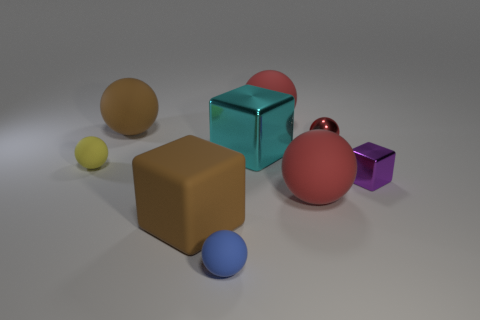The metal block behind the purple cube is what color?
Ensure brevity in your answer.  Cyan. There is a brown thing that is behind the tiny red shiny thing on the left side of the small purple cube; what is its shape?
Provide a short and direct response. Sphere. Do the large cyan object and the large ball that is on the left side of the large cyan object have the same material?
Ensure brevity in your answer.  No. How many red rubber balls are the same size as the yellow thing?
Your answer should be compact. 0. Is the number of cyan shiny cubes that are right of the purple metal block less than the number of tiny blue cylinders?
Make the answer very short. No. There is a small blue object; what number of matte spheres are behind it?
Offer a terse response. 4. There is a block to the right of the red rubber thing behind the big red object in front of the red shiny sphere; how big is it?
Your response must be concise. Small. There is a small purple thing; does it have the same shape as the big brown object in front of the big brown rubber sphere?
Make the answer very short. Yes. There is a yellow ball that is made of the same material as the blue object; what is its size?
Your response must be concise. Small. Are there any other things that have the same color as the big matte block?
Keep it short and to the point. Yes. 